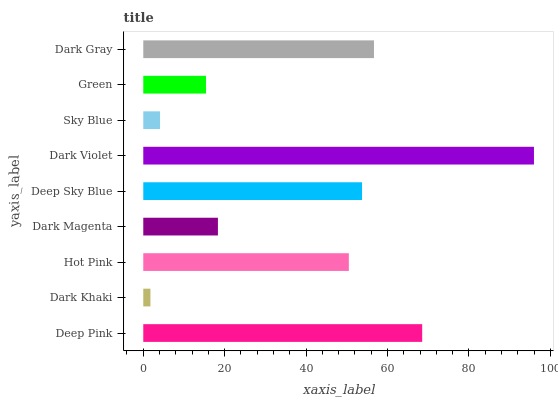Is Dark Khaki the minimum?
Answer yes or no. Yes. Is Dark Violet the maximum?
Answer yes or no. Yes. Is Hot Pink the minimum?
Answer yes or no. No. Is Hot Pink the maximum?
Answer yes or no. No. Is Hot Pink greater than Dark Khaki?
Answer yes or no. Yes. Is Dark Khaki less than Hot Pink?
Answer yes or no. Yes. Is Dark Khaki greater than Hot Pink?
Answer yes or no. No. Is Hot Pink less than Dark Khaki?
Answer yes or no. No. Is Hot Pink the high median?
Answer yes or no. Yes. Is Hot Pink the low median?
Answer yes or no. Yes. Is Sky Blue the high median?
Answer yes or no. No. Is Deep Sky Blue the low median?
Answer yes or no. No. 